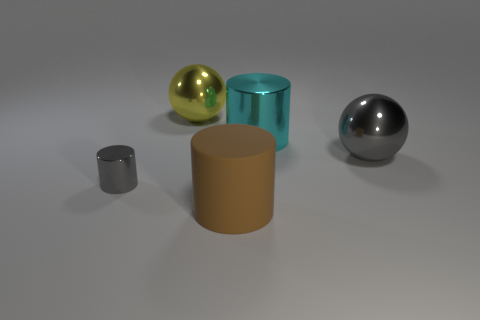Does the small gray metal object have the same shape as the big thing that is in front of the gray cylinder?
Give a very brief answer. Yes. What size is the gray metal object that is the same shape as the cyan thing?
Your answer should be very brief. Small. There is a small shiny cylinder; is it the same color as the large metallic object that is to the left of the big brown cylinder?
Ensure brevity in your answer.  No. How many other things are the same size as the brown object?
Your answer should be very brief. 3. What shape is the gray object on the left side of the metallic cylinder behind the shiny cylinder in front of the cyan thing?
Give a very brief answer. Cylinder. There is a brown cylinder; is it the same size as the gray metal object that is left of the brown rubber cylinder?
Give a very brief answer. No. There is a metallic thing that is both on the right side of the large yellow metal sphere and behind the gray shiny ball; what is its color?
Your answer should be compact. Cyan. What number of other things are there of the same shape as the small metal thing?
Give a very brief answer. 2. There is a shiny cylinder on the left side of the yellow metallic ball; is it the same color as the shiny ball in front of the large yellow shiny ball?
Provide a succinct answer. Yes. There is a gray metallic object that is to the right of the tiny shiny thing; is its size the same as the metallic cylinder on the right side of the yellow metal object?
Offer a terse response. Yes. 